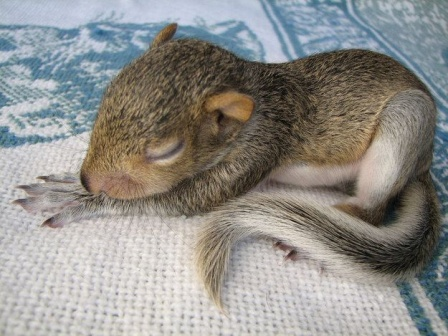What emotions does the baby squirrel evoke? The baby squirrel in the image evokes emotions of warmth, tranquility, and tenderness. Its peaceful slumber and curled-up position convey a sense of safety and comfort, eliciting feelings of nurturing and care. The innocent and serene expression of the tiny creature touches the viewer's heart, reminding us of the delicate nature of life and the beauty of vulnerable moments in the animal kingdom. 